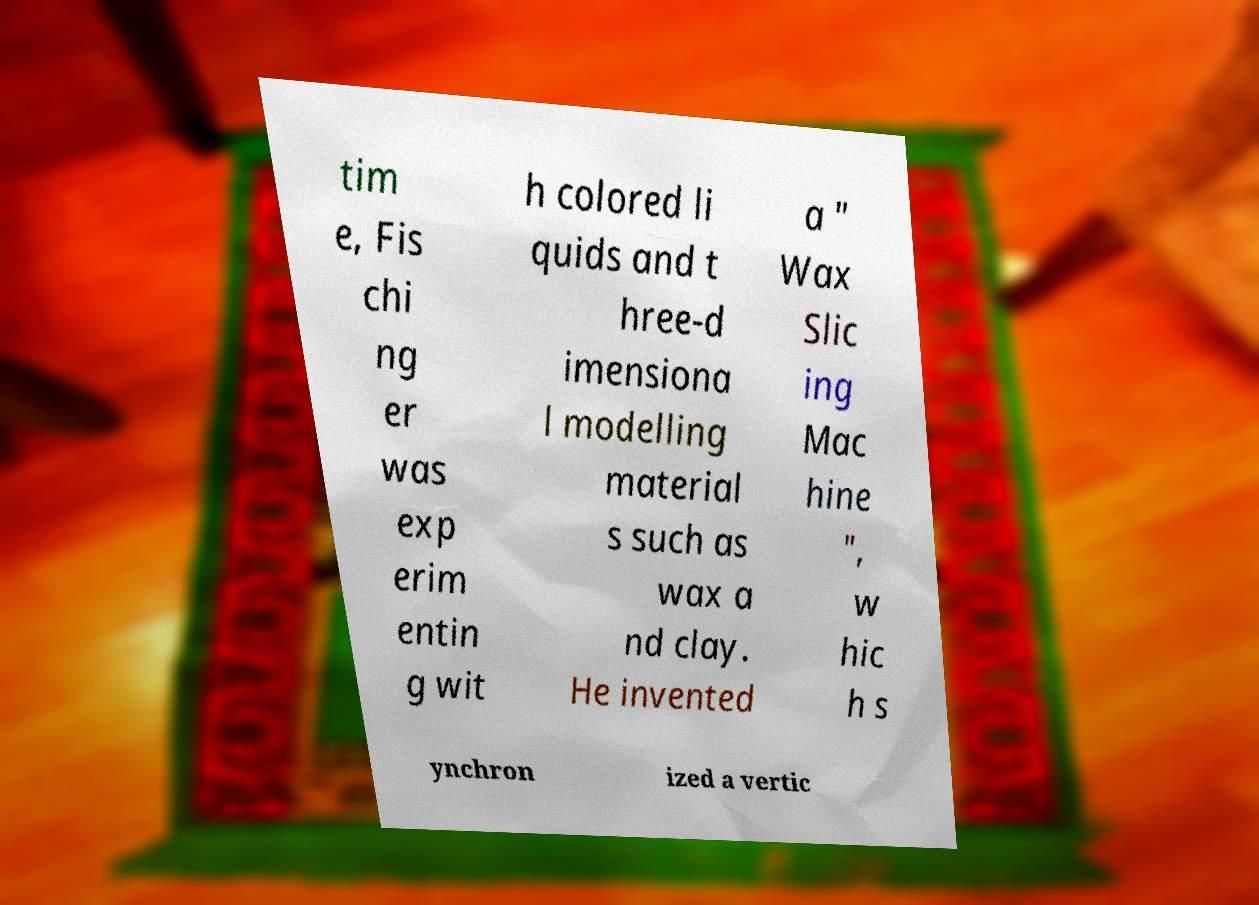I need the written content from this picture converted into text. Can you do that? tim e, Fis chi ng er was exp erim entin g wit h colored li quids and t hree-d imensiona l modelling material s such as wax a nd clay. He invented a " Wax Slic ing Mac hine ", w hic h s ynchron ized a vertic 